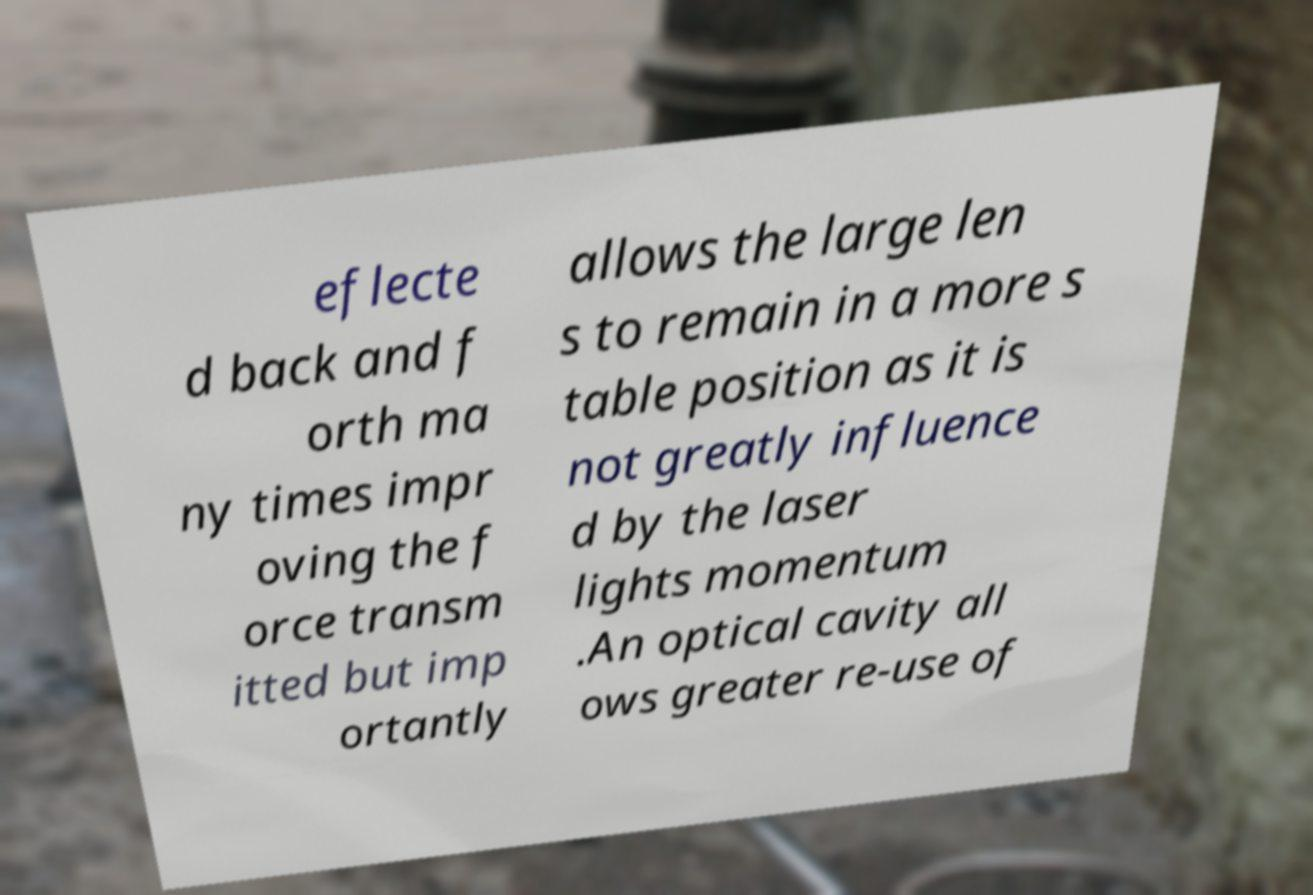Please read and relay the text visible in this image. What does it say? eflecte d back and f orth ma ny times impr oving the f orce transm itted but imp ortantly allows the large len s to remain in a more s table position as it is not greatly influence d by the laser lights momentum .An optical cavity all ows greater re-use of 